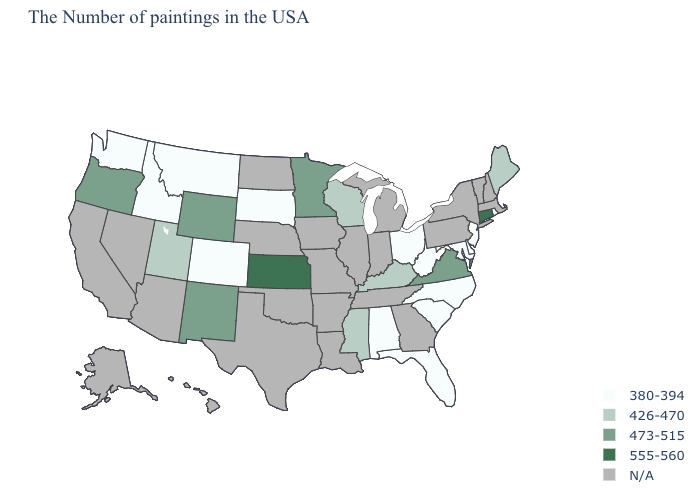Which states have the lowest value in the USA?
Write a very short answer. Rhode Island, New Jersey, Delaware, Maryland, North Carolina, South Carolina, West Virginia, Ohio, Florida, Alabama, South Dakota, Colorado, Montana, Idaho, Washington. Name the states that have a value in the range 426-470?
Keep it brief. Maine, Kentucky, Wisconsin, Mississippi, Utah. Name the states that have a value in the range 473-515?
Answer briefly. Virginia, Minnesota, Wyoming, New Mexico, Oregon. Which states hav the highest value in the South?
Short answer required. Virginia. What is the value of North Dakota?
Be succinct. N/A. What is the value of Mississippi?
Write a very short answer. 426-470. What is the value of Vermont?
Answer briefly. N/A. Which states have the highest value in the USA?
Answer briefly. Connecticut, Kansas. Name the states that have a value in the range 473-515?
Short answer required. Virginia, Minnesota, Wyoming, New Mexico, Oregon. Does the first symbol in the legend represent the smallest category?
Short answer required. Yes. Does the map have missing data?
Write a very short answer. Yes. What is the highest value in states that border Georgia?
Concise answer only. 380-394. Which states have the lowest value in the Northeast?
Give a very brief answer. Rhode Island, New Jersey. 